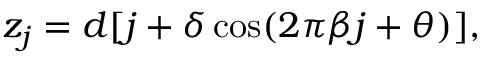<formula> <loc_0><loc_0><loc_500><loc_500>z _ { j } = d [ j + \delta \cos ( 2 \pi \beta j + \theta ) ] ,</formula> 